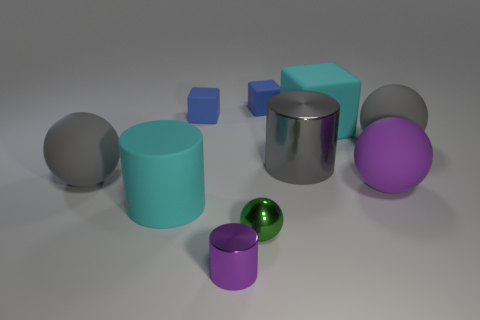Subtract all small blocks. How many blocks are left? 1 Subtract all green balls. How many balls are left? 3 Subtract all blue balls. How many blue cubes are left? 2 Subtract 1 balls. How many balls are left? 3 Subtract 2 blue cubes. How many objects are left? 8 Subtract all balls. How many objects are left? 6 Subtract all purple cylinders. Subtract all gray balls. How many cylinders are left? 2 Subtract all small shiny spheres. Subtract all purple shiny cylinders. How many objects are left? 8 Add 9 green objects. How many green objects are left? 10 Add 7 big gray things. How many big gray things exist? 10 